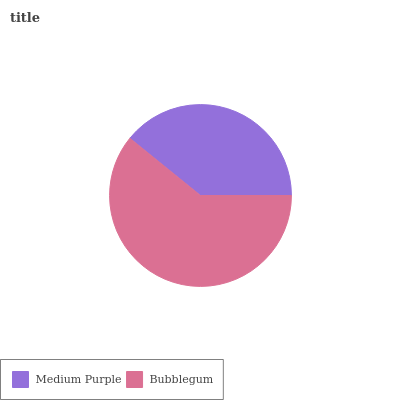Is Medium Purple the minimum?
Answer yes or no. Yes. Is Bubblegum the maximum?
Answer yes or no. Yes. Is Bubblegum the minimum?
Answer yes or no. No. Is Bubblegum greater than Medium Purple?
Answer yes or no. Yes. Is Medium Purple less than Bubblegum?
Answer yes or no. Yes. Is Medium Purple greater than Bubblegum?
Answer yes or no. No. Is Bubblegum less than Medium Purple?
Answer yes or no. No. Is Bubblegum the high median?
Answer yes or no. Yes. Is Medium Purple the low median?
Answer yes or no. Yes. Is Medium Purple the high median?
Answer yes or no. No. Is Bubblegum the low median?
Answer yes or no. No. 